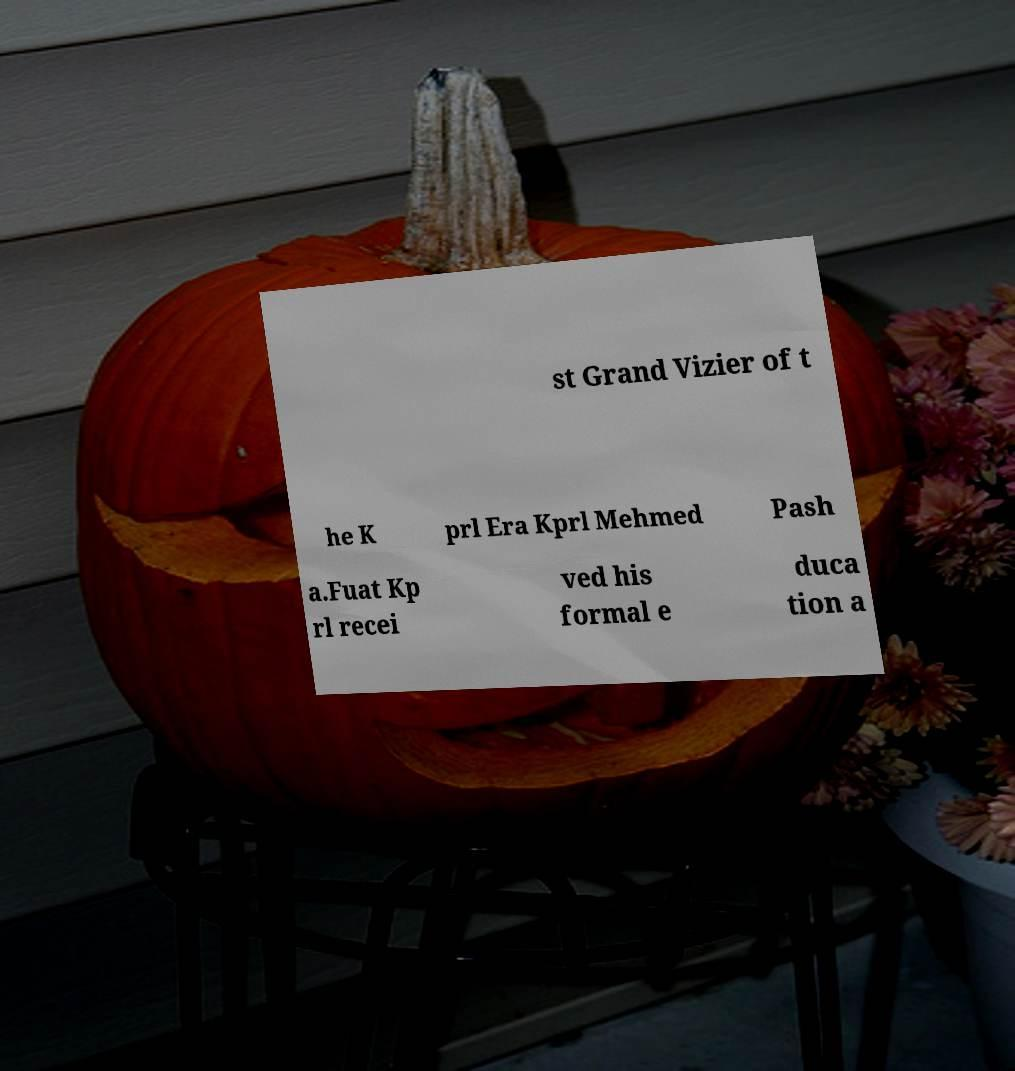Could you assist in decoding the text presented in this image and type it out clearly? st Grand Vizier of t he K prl Era Kprl Mehmed Pash a.Fuat Kp rl recei ved his formal e duca tion a 